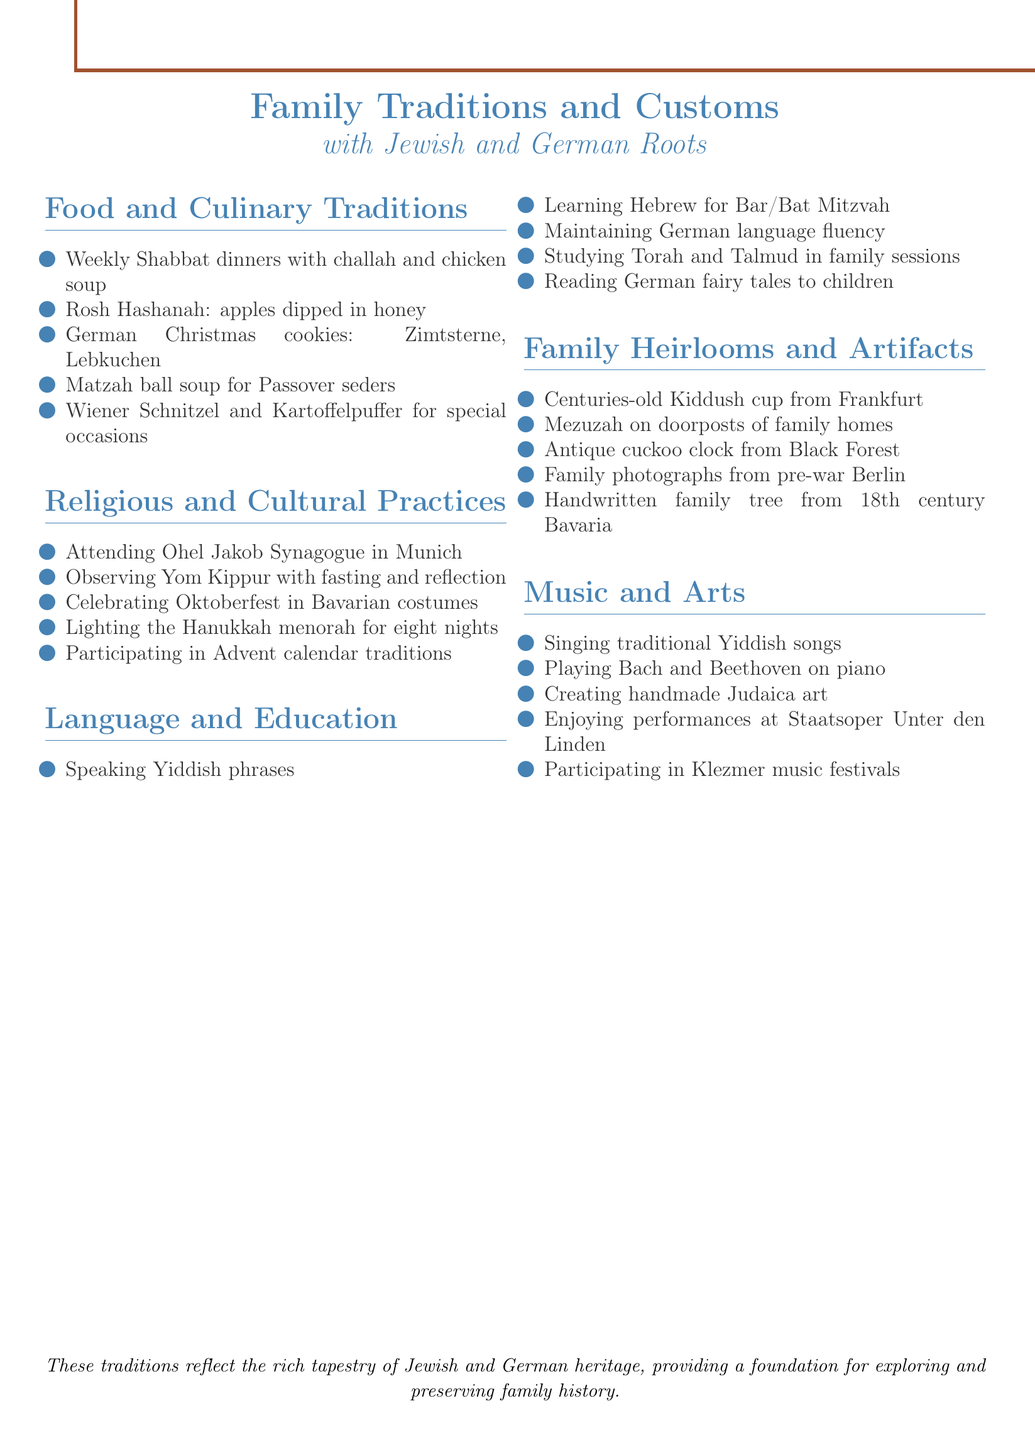What food is served at weekly Shabbat dinners? The document mentions "challah bread and chicken soup" as the food served at weekly Shabbat dinners.
Answer: challah bread and chicken soup What is celebrated during Rosh Hashanah? The document states that apples are dipped in honey during the Rosh Hashanah celebration.
Answer: apples dipped in honey Which synagogue is mentioned in the document? The document specifies attending "Ohel Jakob Synagogue in Munich" as part of religious practices.
Answer: Ohel Jakob Synagogue in Munich What traditional activity takes place in December? The document refers to "participating in Advent calendar traditions" as a traditional activity in December.
Answer: participating in Advent calendar traditions Which German fairy tales are read to children? The document lists "Grimm's Fairy Tales" as the German fairy tales that are read to children.
Answer: Grimm's Fairy Tales What type of historical artifact is mentioned related to family homes? The document contains a mention of a "Mezuzah" on doorposts of family homes as a historical artifact.
Answer: Mezuzah What type of music is sung in the family? The document notes that the family sings "traditional Yiddish songs" as part of their music traditions.
Answer: traditional Yiddish songs What is the importance of the Kiddush cup mentioned? The document states that it is a "centuries-old" item preserved from Frankfurt, indicating its historical significance.
Answer: centuries-old Kiddush cup What cultural festival is celebrated with Bavarian costumes? According to the document, Oktoberfest is celebrated with traditional Bavarian costumes.
Answer: Oktoberfest 